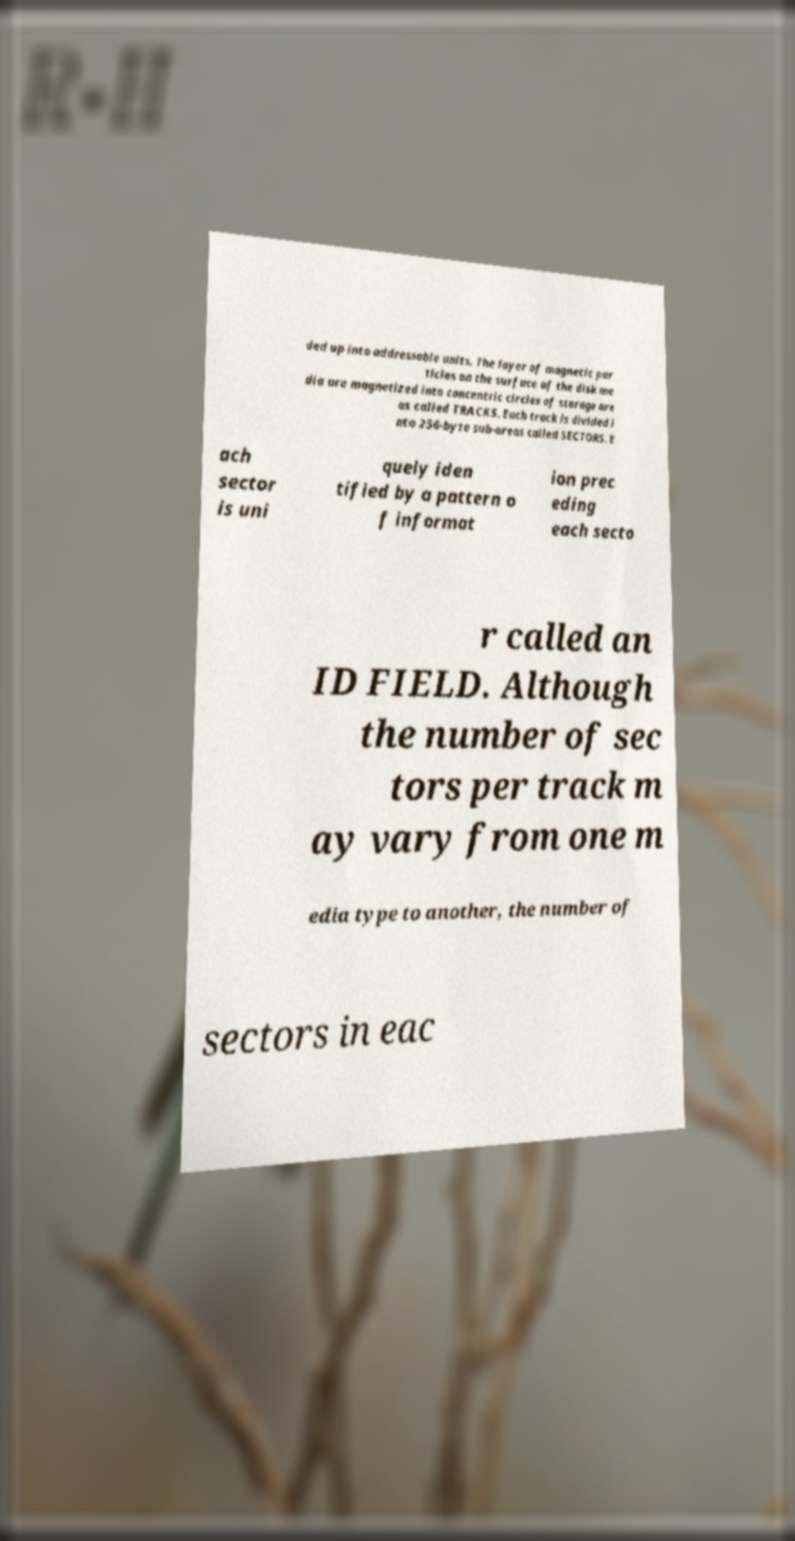Can you accurately transcribe the text from the provided image for me? ded up into addressable units. The layer of magnetic par ticles on the surface of the disk me dia are magnetized into concentric circles of storage are as called TRACKS. Each track is divided i nto 256-byte sub-areas called SECTORS. E ach sector is uni quely iden tified by a pattern o f informat ion prec eding each secto r called an ID FIELD. Although the number of sec tors per track m ay vary from one m edia type to another, the number of sectors in eac 